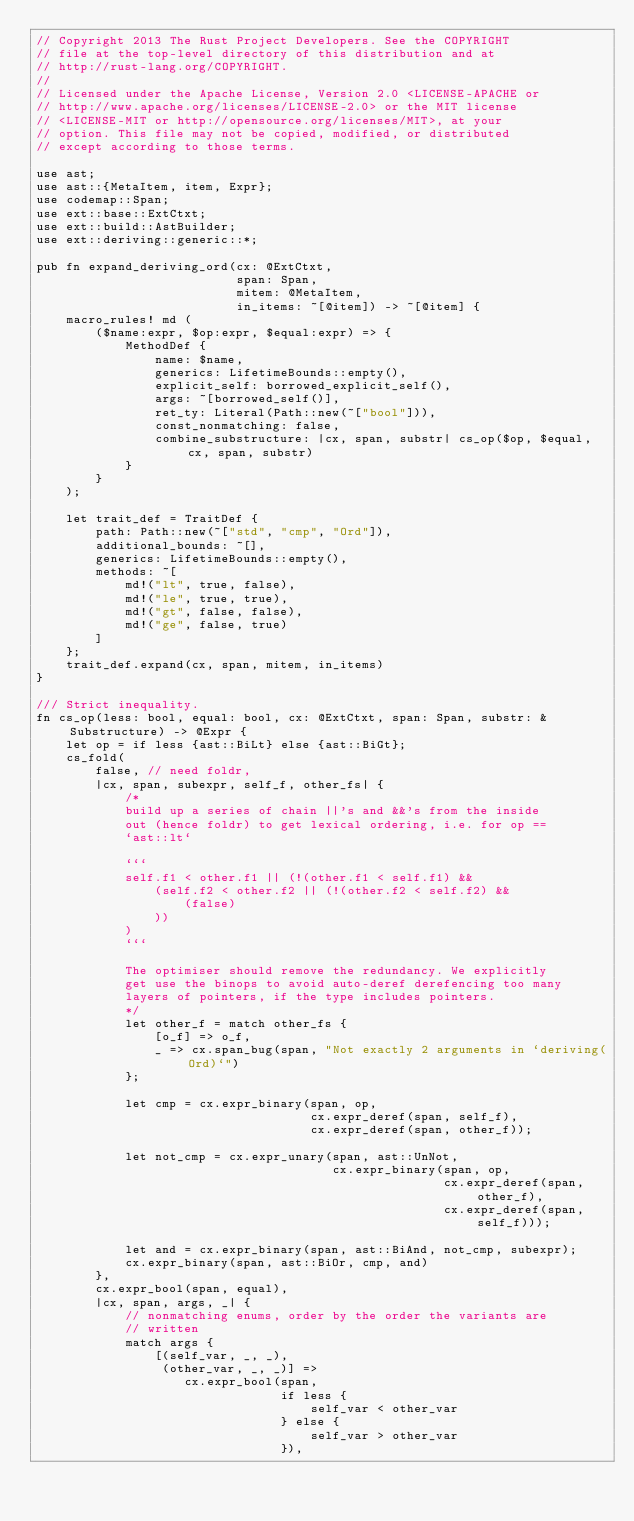<code> <loc_0><loc_0><loc_500><loc_500><_Rust_>// Copyright 2013 The Rust Project Developers. See the COPYRIGHT
// file at the top-level directory of this distribution and at
// http://rust-lang.org/COPYRIGHT.
//
// Licensed under the Apache License, Version 2.0 <LICENSE-APACHE or
// http://www.apache.org/licenses/LICENSE-2.0> or the MIT license
// <LICENSE-MIT or http://opensource.org/licenses/MIT>, at your
// option. This file may not be copied, modified, or distributed
// except according to those terms.

use ast;
use ast::{MetaItem, item, Expr};
use codemap::Span;
use ext::base::ExtCtxt;
use ext::build::AstBuilder;
use ext::deriving::generic::*;

pub fn expand_deriving_ord(cx: @ExtCtxt,
                           span: Span,
                           mitem: @MetaItem,
                           in_items: ~[@item]) -> ~[@item] {
    macro_rules! md (
        ($name:expr, $op:expr, $equal:expr) => {
            MethodDef {
                name: $name,
                generics: LifetimeBounds::empty(),
                explicit_self: borrowed_explicit_self(),
                args: ~[borrowed_self()],
                ret_ty: Literal(Path::new(~["bool"])),
                const_nonmatching: false,
                combine_substructure: |cx, span, substr| cs_op($op, $equal, cx, span, substr)
            }
        }
    );

    let trait_def = TraitDef {
        path: Path::new(~["std", "cmp", "Ord"]),
        additional_bounds: ~[],
        generics: LifetimeBounds::empty(),
        methods: ~[
            md!("lt", true, false),
            md!("le", true, true),
            md!("gt", false, false),
            md!("ge", false, true)
        ]
    };
    trait_def.expand(cx, span, mitem, in_items)
}

/// Strict inequality.
fn cs_op(less: bool, equal: bool, cx: @ExtCtxt, span: Span, substr: &Substructure) -> @Expr {
    let op = if less {ast::BiLt} else {ast::BiGt};
    cs_fold(
        false, // need foldr,
        |cx, span, subexpr, self_f, other_fs| {
            /*
            build up a series of chain ||'s and &&'s from the inside
            out (hence foldr) to get lexical ordering, i.e. for op ==
            `ast::lt`

            ```
            self.f1 < other.f1 || (!(other.f1 < self.f1) &&
                (self.f2 < other.f2 || (!(other.f2 < self.f2) &&
                    (false)
                ))
            )
            ```

            The optimiser should remove the redundancy. We explicitly
            get use the binops to avoid auto-deref derefencing too many
            layers of pointers, if the type includes pointers.
            */
            let other_f = match other_fs {
                [o_f] => o_f,
                _ => cx.span_bug(span, "Not exactly 2 arguments in `deriving(Ord)`")
            };

            let cmp = cx.expr_binary(span, op,
                                     cx.expr_deref(span, self_f),
                                     cx.expr_deref(span, other_f));

            let not_cmp = cx.expr_unary(span, ast::UnNot,
                                        cx.expr_binary(span, op,
                                                       cx.expr_deref(span, other_f),
                                                       cx.expr_deref(span, self_f)));

            let and = cx.expr_binary(span, ast::BiAnd, not_cmp, subexpr);
            cx.expr_binary(span, ast::BiOr, cmp, and)
        },
        cx.expr_bool(span, equal),
        |cx, span, args, _| {
            // nonmatching enums, order by the order the variants are
            // written
            match args {
                [(self_var, _, _),
                 (other_var, _, _)] =>
                    cx.expr_bool(span,
                                 if less {
                                     self_var < other_var
                                 } else {
                                     self_var > other_var
                                 }),</code> 